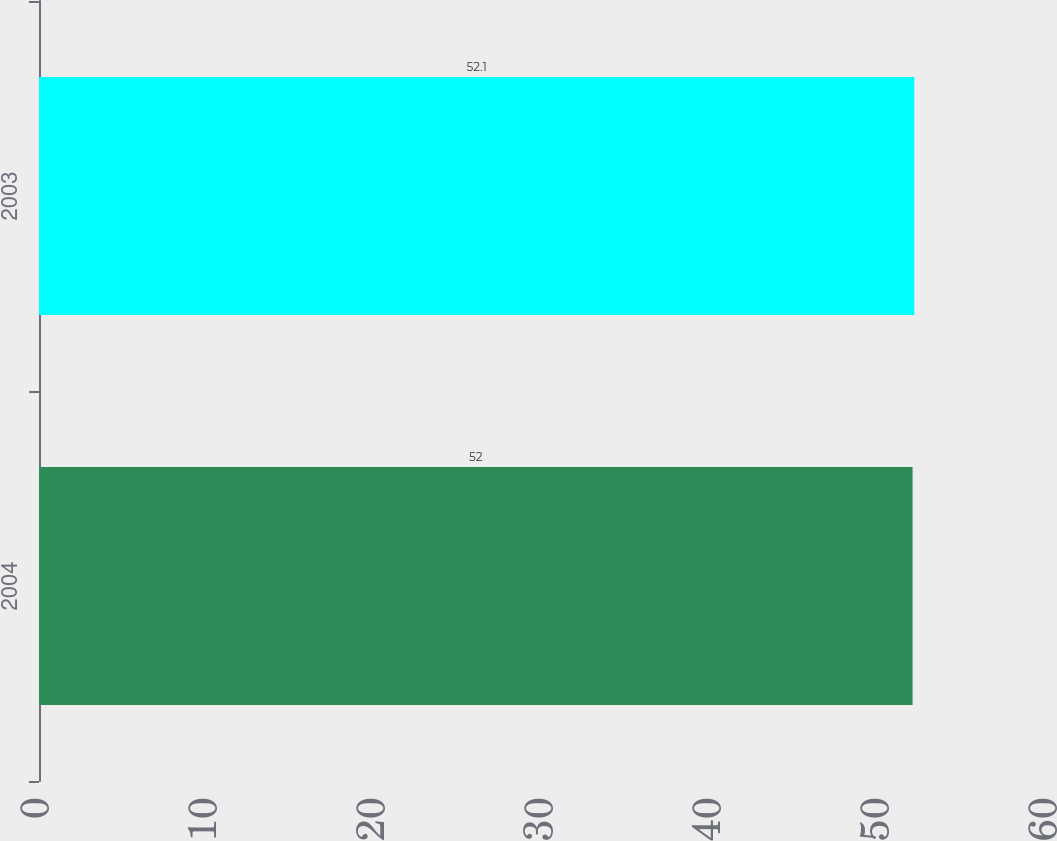Convert chart to OTSL. <chart><loc_0><loc_0><loc_500><loc_500><bar_chart><fcel>2004<fcel>2003<nl><fcel>52<fcel>52.1<nl></chart> 